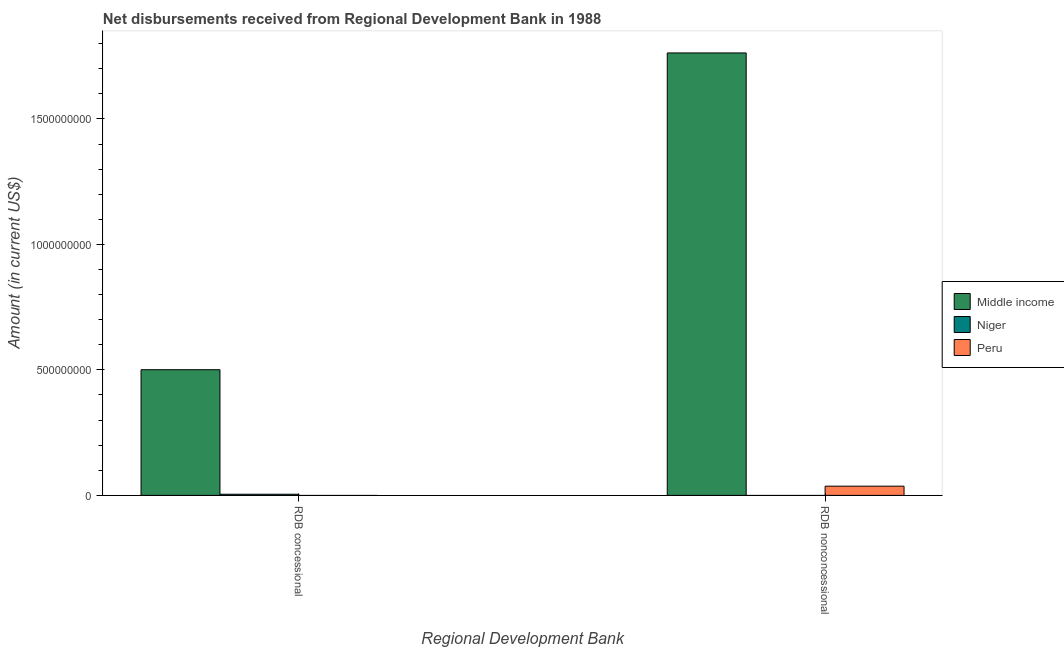How many different coloured bars are there?
Keep it short and to the point. 3. How many groups of bars are there?
Your response must be concise. 2. How many bars are there on the 1st tick from the left?
Offer a very short reply. 2. What is the label of the 1st group of bars from the left?
Provide a short and direct response. RDB concessional. What is the net concessional disbursements from rdb in Middle income?
Your answer should be very brief. 5.01e+08. Across all countries, what is the maximum net concessional disbursements from rdb?
Ensure brevity in your answer.  5.01e+08. What is the total net concessional disbursements from rdb in the graph?
Ensure brevity in your answer.  5.05e+08. What is the difference between the net non concessional disbursements from rdb in Peru and that in Middle income?
Your answer should be very brief. -1.73e+09. What is the difference between the net non concessional disbursements from rdb in Middle income and the net concessional disbursements from rdb in Peru?
Make the answer very short. 1.76e+09. What is the average net non concessional disbursements from rdb per country?
Keep it short and to the point. 6.00e+08. What is the difference between the net concessional disbursements from rdb and net non concessional disbursements from rdb in Middle income?
Ensure brevity in your answer.  -1.26e+09. In how many countries, is the net concessional disbursements from rdb greater than 300000000 US$?
Make the answer very short. 1. What is the ratio of the net concessional disbursements from rdb in Niger to that in Middle income?
Your response must be concise. 0.01. Is the net non concessional disbursements from rdb in Peru less than that in Middle income?
Offer a terse response. Yes. How many bars are there?
Your answer should be compact. 4. How many countries are there in the graph?
Make the answer very short. 3. Are the values on the major ticks of Y-axis written in scientific E-notation?
Keep it short and to the point. No. Does the graph contain any zero values?
Your response must be concise. Yes. How many legend labels are there?
Your response must be concise. 3. How are the legend labels stacked?
Your answer should be very brief. Vertical. What is the title of the graph?
Give a very brief answer. Net disbursements received from Regional Development Bank in 1988. Does "Kenya" appear as one of the legend labels in the graph?
Offer a terse response. No. What is the label or title of the X-axis?
Your response must be concise. Regional Development Bank. What is the label or title of the Y-axis?
Provide a short and direct response. Amount (in current US$). What is the Amount (in current US$) in Middle income in RDB concessional?
Offer a very short reply. 5.01e+08. What is the Amount (in current US$) of Niger in RDB concessional?
Your answer should be very brief. 4.56e+06. What is the Amount (in current US$) in Peru in RDB concessional?
Offer a terse response. 0. What is the Amount (in current US$) of Middle income in RDB nonconcessional?
Provide a short and direct response. 1.76e+09. What is the Amount (in current US$) of Peru in RDB nonconcessional?
Provide a succinct answer. 3.68e+07. Across all Regional Development Bank, what is the maximum Amount (in current US$) of Middle income?
Offer a terse response. 1.76e+09. Across all Regional Development Bank, what is the maximum Amount (in current US$) of Niger?
Keep it short and to the point. 4.56e+06. Across all Regional Development Bank, what is the maximum Amount (in current US$) in Peru?
Ensure brevity in your answer.  3.68e+07. Across all Regional Development Bank, what is the minimum Amount (in current US$) in Middle income?
Offer a terse response. 5.01e+08. Across all Regional Development Bank, what is the minimum Amount (in current US$) of Peru?
Provide a succinct answer. 0. What is the total Amount (in current US$) of Middle income in the graph?
Offer a terse response. 2.26e+09. What is the total Amount (in current US$) of Niger in the graph?
Make the answer very short. 4.56e+06. What is the total Amount (in current US$) in Peru in the graph?
Provide a short and direct response. 3.68e+07. What is the difference between the Amount (in current US$) in Middle income in RDB concessional and that in RDB nonconcessional?
Provide a succinct answer. -1.26e+09. What is the difference between the Amount (in current US$) in Middle income in RDB concessional and the Amount (in current US$) in Peru in RDB nonconcessional?
Ensure brevity in your answer.  4.64e+08. What is the difference between the Amount (in current US$) in Niger in RDB concessional and the Amount (in current US$) in Peru in RDB nonconcessional?
Your response must be concise. -3.22e+07. What is the average Amount (in current US$) of Middle income per Regional Development Bank?
Make the answer very short. 1.13e+09. What is the average Amount (in current US$) in Niger per Regional Development Bank?
Make the answer very short. 2.28e+06. What is the average Amount (in current US$) in Peru per Regional Development Bank?
Make the answer very short. 1.84e+07. What is the difference between the Amount (in current US$) of Middle income and Amount (in current US$) of Niger in RDB concessional?
Your answer should be compact. 4.96e+08. What is the difference between the Amount (in current US$) in Middle income and Amount (in current US$) in Peru in RDB nonconcessional?
Make the answer very short. 1.73e+09. What is the ratio of the Amount (in current US$) of Middle income in RDB concessional to that in RDB nonconcessional?
Keep it short and to the point. 0.28. What is the difference between the highest and the second highest Amount (in current US$) in Middle income?
Provide a short and direct response. 1.26e+09. What is the difference between the highest and the lowest Amount (in current US$) of Middle income?
Your response must be concise. 1.26e+09. What is the difference between the highest and the lowest Amount (in current US$) of Niger?
Keep it short and to the point. 4.56e+06. What is the difference between the highest and the lowest Amount (in current US$) in Peru?
Ensure brevity in your answer.  3.68e+07. 